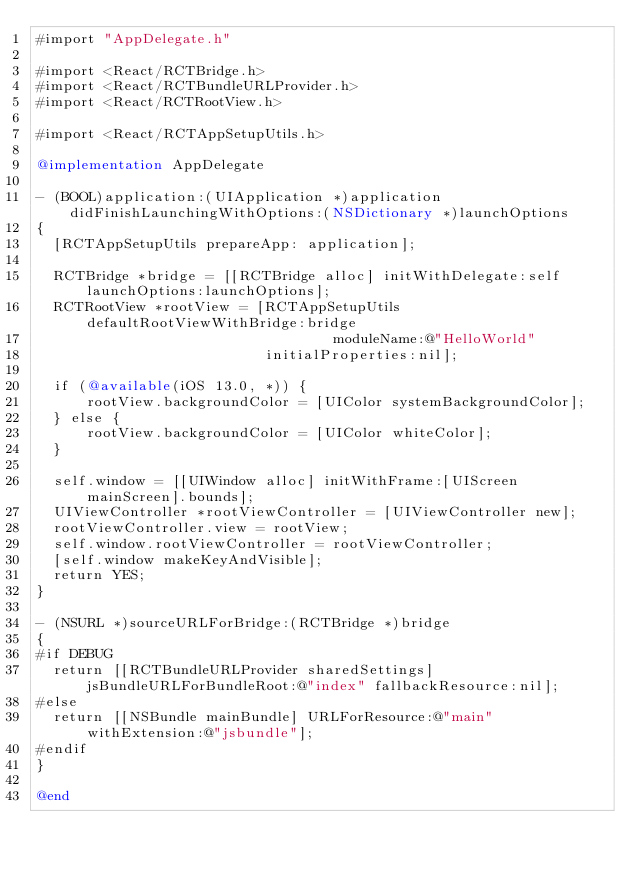<code> <loc_0><loc_0><loc_500><loc_500><_ObjectiveC_>#import "AppDelegate.h"

#import <React/RCTBridge.h>
#import <React/RCTBundleURLProvider.h>
#import <React/RCTRootView.h>

#import <React/RCTAppSetupUtils.h>

@implementation AppDelegate

- (BOOL)application:(UIApplication *)application didFinishLaunchingWithOptions:(NSDictionary *)launchOptions
{
  [RCTAppSetupUtils prepareApp: application];

  RCTBridge *bridge = [[RCTBridge alloc] initWithDelegate:self launchOptions:launchOptions];
  RCTRootView *rootView = [RCTAppSetupUtils defaultRootViewWithBridge:bridge
                                   moduleName:@"HelloWorld"
                           initialProperties:nil];

  if (@available(iOS 13.0, *)) {
      rootView.backgroundColor = [UIColor systemBackgroundColor];
  } else {
      rootView.backgroundColor = [UIColor whiteColor];
  }

  self.window = [[UIWindow alloc] initWithFrame:[UIScreen mainScreen].bounds];
  UIViewController *rootViewController = [UIViewController new];
  rootViewController.view = rootView;
  self.window.rootViewController = rootViewController;
  [self.window makeKeyAndVisible];
  return YES;
}

- (NSURL *)sourceURLForBridge:(RCTBridge *)bridge
{
#if DEBUG
  return [[RCTBundleURLProvider sharedSettings] jsBundleURLForBundleRoot:@"index" fallbackResource:nil];
#else
  return [[NSBundle mainBundle] URLForResource:@"main" withExtension:@"jsbundle"];
#endif
}

@end
</code> 